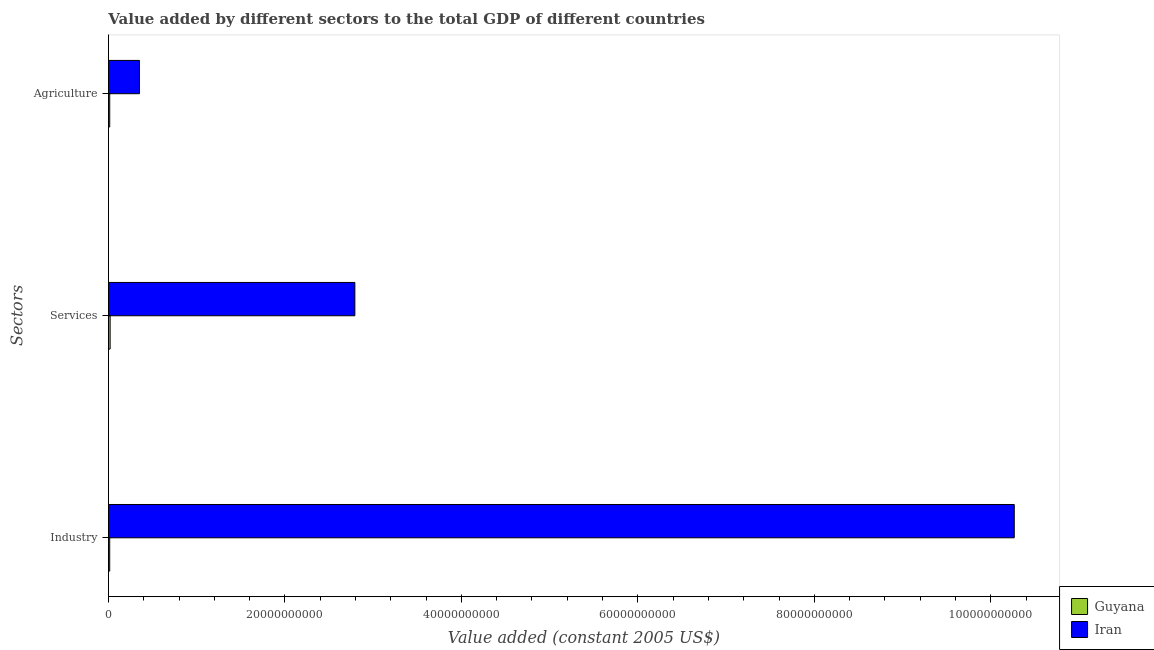How many different coloured bars are there?
Offer a very short reply. 2. Are the number of bars per tick equal to the number of legend labels?
Ensure brevity in your answer.  Yes. Are the number of bars on each tick of the Y-axis equal?
Your response must be concise. Yes. What is the label of the 1st group of bars from the top?
Give a very brief answer. Agriculture. What is the value added by industrial sector in Guyana?
Keep it short and to the point. 1.44e+08. Across all countries, what is the maximum value added by industrial sector?
Give a very brief answer. 1.03e+11. Across all countries, what is the minimum value added by services?
Offer a very short reply. 1.92e+08. In which country was the value added by industrial sector maximum?
Provide a short and direct response. Iran. In which country was the value added by services minimum?
Make the answer very short. Guyana. What is the total value added by services in the graph?
Give a very brief answer. 2.81e+1. What is the difference between the value added by industrial sector in Guyana and that in Iran?
Offer a terse response. -1.03e+11. What is the difference between the value added by industrial sector in Iran and the value added by agricultural sector in Guyana?
Ensure brevity in your answer.  1.03e+11. What is the average value added by industrial sector per country?
Your response must be concise. 5.14e+1. What is the difference between the value added by industrial sector and value added by agricultural sector in Guyana?
Offer a terse response. -2.09e+06. What is the ratio of the value added by industrial sector in Guyana to that in Iran?
Offer a very short reply. 0. Is the difference between the value added by industrial sector in Guyana and Iran greater than the difference between the value added by agricultural sector in Guyana and Iran?
Offer a very short reply. No. What is the difference between the highest and the second highest value added by agricultural sector?
Provide a succinct answer. 3.37e+09. What is the difference between the highest and the lowest value added by services?
Keep it short and to the point. 2.77e+1. Is the sum of the value added by services in Iran and Guyana greater than the maximum value added by industrial sector across all countries?
Provide a succinct answer. No. What does the 2nd bar from the top in Agriculture represents?
Provide a short and direct response. Guyana. What does the 1st bar from the bottom in Services represents?
Your answer should be very brief. Guyana. Is it the case that in every country, the sum of the value added by industrial sector and value added by services is greater than the value added by agricultural sector?
Your answer should be very brief. Yes. What is the difference between two consecutive major ticks on the X-axis?
Offer a very short reply. 2.00e+1. Does the graph contain any zero values?
Provide a succinct answer. No. How many legend labels are there?
Ensure brevity in your answer.  2. How are the legend labels stacked?
Offer a very short reply. Vertical. What is the title of the graph?
Keep it short and to the point. Value added by different sectors to the total GDP of different countries. Does "United States" appear as one of the legend labels in the graph?
Your response must be concise. No. What is the label or title of the X-axis?
Offer a terse response. Value added (constant 2005 US$). What is the label or title of the Y-axis?
Give a very brief answer. Sectors. What is the Value added (constant 2005 US$) of Guyana in Industry?
Provide a succinct answer. 1.44e+08. What is the Value added (constant 2005 US$) in Iran in Industry?
Your response must be concise. 1.03e+11. What is the Value added (constant 2005 US$) in Guyana in Services?
Your answer should be very brief. 1.92e+08. What is the Value added (constant 2005 US$) in Iran in Services?
Provide a short and direct response. 2.79e+1. What is the Value added (constant 2005 US$) in Guyana in Agriculture?
Keep it short and to the point. 1.46e+08. What is the Value added (constant 2005 US$) of Iran in Agriculture?
Ensure brevity in your answer.  3.52e+09. Across all Sectors, what is the maximum Value added (constant 2005 US$) of Guyana?
Make the answer very short. 1.92e+08. Across all Sectors, what is the maximum Value added (constant 2005 US$) of Iran?
Your response must be concise. 1.03e+11. Across all Sectors, what is the minimum Value added (constant 2005 US$) in Guyana?
Your answer should be compact. 1.44e+08. Across all Sectors, what is the minimum Value added (constant 2005 US$) in Iran?
Provide a succinct answer. 3.52e+09. What is the total Value added (constant 2005 US$) in Guyana in the graph?
Your answer should be very brief. 4.81e+08. What is the total Value added (constant 2005 US$) of Iran in the graph?
Provide a short and direct response. 1.34e+11. What is the difference between the Value added (constant 2005 US$) of Guyana in Industry and that in Services?
Offer a terse response. -4.79e+07. What is the difference between the Value added (constant 2005 US$) in Iran in Industry and that in Services?
Give a very brief answer. 7.47e+1. What is the difference between the Value added (constant 2005 US$) of Guyana in Industry and that in Agriculture?
Your response must be concise. -2.09e+06. What is the difference between the Value added (constant 2005 US$) in Iran in Industry and that in Agriculture?
Your answer should be compact. 9.91e+1. What is the difference between the Value added (constant 2005 US$) of Guyana in Services and that in Agriculture?
Provide a succinct answer. 4.58e+07. What is the difference between the Value added (constant 2005 US$) of Iran in Services and that in Agriculture?
Provide a short and direct response. 2.44e+1. What is the difference between the Value added (constant 2005 US$) in Guyana in Industry and the Value added (constant 2005 US$) in Iran in Services?
Offer a terse response. -2.78e+1. What is the difference between the Value added (constant 2005 US$) of Guyana in Industry and the Value added (constant 2005 US$) of Iran in Agriculture?
Your answer should be very brief. -3.37e+09. What is the difference between the Value added (constant 2005 US$) of Guyana in Services and the Value added (constant 2005 US$) of Iran in Agriculture?
Provide a short and direct response. -3.33e+09. What is the average Value added (constant 2005 US$) in Guyana per Sectors?
Provide a succinct answer. 1.60e+08. What is the average Value added (constant 2005 US$) in Iran per Sectors?
Ensure brevity in your answer.  4.47e+1. What is the difference between the Value added (constant 2005 US$) of Guyana and Value added (constant 2005 US$) of Iran in Industry?
Keep it short and to the point. -1.03e+11. What is the difference between the Value added (constant 2005 US$) of Guyana and Value added (constant 2005 US$) of Iran in Services?
Keep it short and to the point. -2.77e+1. What is the difference between the Value added (constant 2005 US$) in Guyana and Value added (constant 2005 US$) in Iran in Agriculture?
Provide a succinct answer. -3.37e+09. What is the ratio of the Value added (constant 2005 US$) in Guyana in Industry to that in Services?
Ensure brevity in your answer.  0.75. What is the ratio of the Value added (constant 2005 US$) of Iran in Industry to that in Services?
Your response must be concise. 3.68. What is the ratio of the Value added (constant 2005 US$) in Guyana in Industry to that in Agriculture?
Offer a very short reply. 0.99. What is the ratio of the Value added (constant 2005 US$) in Iran in Industry to that in Agriculture?
Offer a terse response. 29.18. What is the ratio of the Value added (constant 2005 US$) in Guyana in Services to that in Agriculture?
Give a very brief answer. 1.31. What is the ratio of the Value added (constant 2005 US$) in Iran in Services to that in Agriculture?
Offer a very short reply. 7.94. What is the difference between the highest and the second highest Value added (constant 2005 US$) of Guyana?
Provide a short and direct response. 4.58e+07. What is the difference between the highest and the second highest Value added (constant 2005 US$) of Iran?
Provide a short and direct response. 7.47e+1. What is the difference between the highest and the lowest Value added (constant 2005 US$) of Guyana?
Provide a short and direct response. 4.79e+07. What is the difference between the highest and the lowest Value added (constant 2005 US$) in Iran?
Your answer should be very brief. 9.91e+1. 